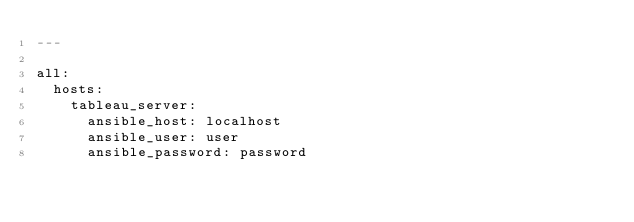<code> <loc_0><loc_0><loc_500><loc_500><_YAML_>---

all:
  hosts:
    tableau_server:
      ansible_host: localhost
      ansible_user: user
      ansible_password: password</code> 